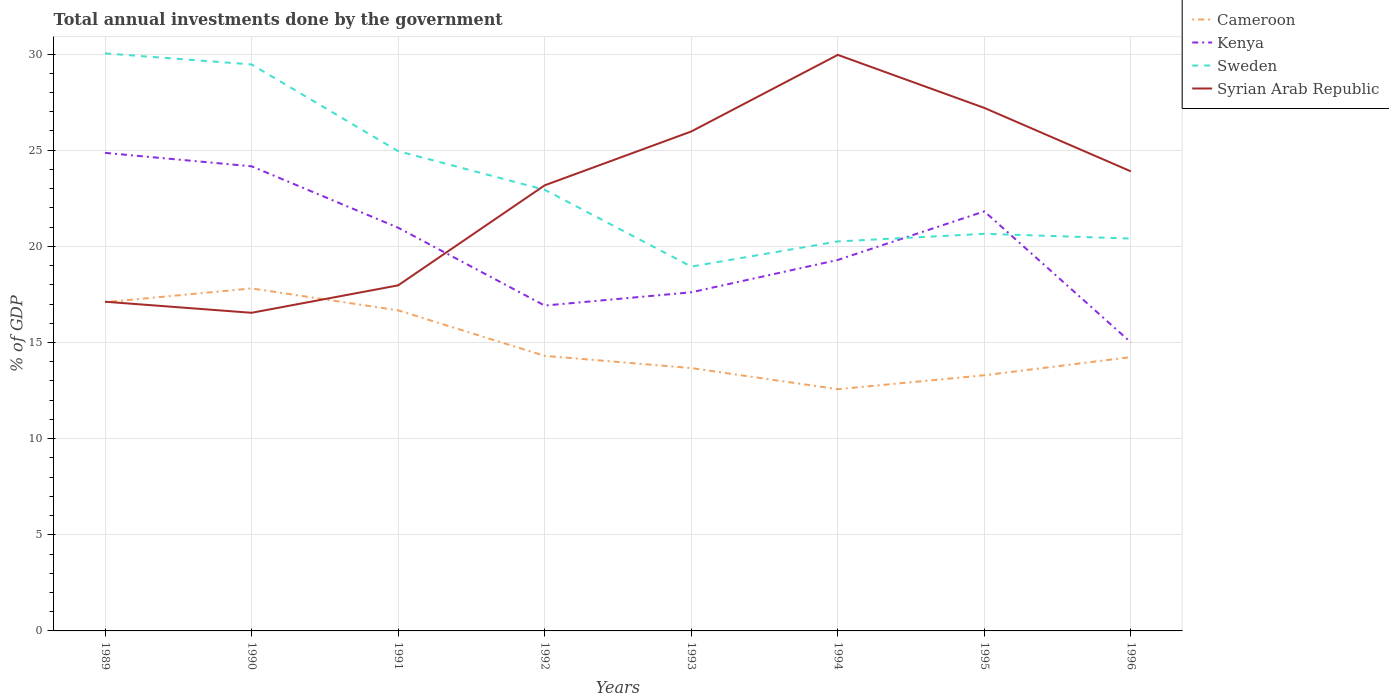Does the line corresponding to Syrian Arab Republic intersect with the line corresponding to Cameroon?
Offer a terse response. Yes. Is the number of lines equal to the number of legend labels?
Give a very brief answer. Yes. Across all years, what is the maximum total annual investments done by the government in Sweden?
Offer a very short reply. 18.95. What is the total total annual investments done by the government in Cameroon in the graph?
Ensure brevity in your answer.  2.79. What is the difference between the highest and the second highest total annual investments done by the government in Sweden?
Your answer should be compact. 11.09. Is the total annual investments done by the government in Cameroon strictly greater than the total annual investments done by the government in Sweden over the years?
Keep it short and to the point. Yes. How many lines are there?
Give a very brief answer. 4. How many years are there in the graph?
Provide a succinct answer. 8. What is the difference between two consecutive major ticks on the Y-axis?
Your answer should be very brief. 5. Are the values on the major ticks of Y-axis written in scientific E-notation?
Your response must be concise. No. Where does the legend appear in the graph?
Provide a short and direct response. Top right. How many legend labels are there?
Your answer should be compact. 4. What is the title of the graph?
Offer a terse response. Total annual investments done by the government. Does "Yemen, Rep." appear as one of the legend labels in the graph?
Offer a terse response. No. What is the label or title of the X-axis?
Provide a succinct answer. Years. What is the label or title of the Y-axis?
Ensure brevity in your answer.  % of GDP. What is the % of GDP in Cameroon in 1989?
Provide a succinct answer. 17.1. What is the % of GDP in Kenya in 1989?
Your response must be concise. 24.86. What is the % of GDP of Sweden in 1989?
Provide a short and direct response. 30.04. What is the % of GDP of Syrian Arab Republic in 1989?
Offer a very short reply. 17.12. What is the % of GDP in Cameroon in 1990?
Your answer should be compact. 17.81. What is the % of GDP in Kenya in 1990?
Your answer should be very brief. 24.16. What is the % of GDP of Sweden in 1990?
Your answer should be compact. 29.46. What is the % of GDP in Syrian Arab Republic in 1990?
Your answer should be compact. 16.55. What is the % of GDP in Cameroon in 1991?
Your answer should be compact. 16.67. What is the % of GDP in Kenya in 1991?
Provide a short and direct response. 20.97. What is the % of GDP of Sweden in 1991?
Provide a succinct answer. 24.95. What is the % of GDP in Syrian Arab Republic in 1991?
Provide a succinct answer. 17.97. What is the % of GDP of Cameroon in 1992?
Your response must be concise. 14.31. What is the % of GDP in Kenya in 1992?
Your answer should be compact. 16.92. What is the % of GDP in Sweden in 1992?
Make the answer very short. 22.94. What is the % of GDP in Syrian Arab Republic in 1992?
Your answer should be very brief. 23.17. What is the % of GDP in Cameroon in 1993?
Provide a short and direct response. 13.67. What is the % of GDP of Kenya in 1993?
Provide a short and direct response. 17.61. What is the % of GDP of Sweden in 1993?
Give a very brief answer. 18.95. What is the % of GDP in Syrian Arab Republic in 1993?
Give a very brief answer. 25.97. What is the % of GDP of Cameroon in 1994?
Provide a succinct answer. 12.57. What is the % of GDP of Kenya in 1994?
Make the answer very short. 19.29. What is the % of GDP in Sweden in 1994?
Ensure brevity in your answer.  20.26. What is the % of GDP in Syrian Arab Republic in 1994?
Keep it short and to the point. 29.96. What is the % of GDP in Cameroon in 1995?
Offer a terse response. 13.3. What is the % of GDP in Kenya in 1995?
Your response must be concise. 21.82. What is the % of GDP in Sweden in 1995?
Your answer should be very brief. 20.65. What is the % of GDP of Syrian Arab Republic in 1995?
Offer a terse response. 27.2. What is the % of GDP of Cameroon in 1996?
Offer a terse response. 14.24. What is the % of GDP of Kenya in 1996?
Offer a very short reply. 15. What is the % of GDP of Sweden in 1996?
Offer a very short reply. 20.41. What is the % of GDP in Syrian Arab Republic in 1996?
Offer a terse response. 23.9. Across all years, what is the maximum % of GDP in Cameroon?
Your answer should be very brief. 17.81. Across all years, what is the maximum % of GDP in Kenya?
Your answer should be very brief. 24.86. Across all years, what is the maximum % of GDP in Sweden?
Keep it short and to the point. 30.04. Across all years, what is the maximum % of GDP of Syrian Arab Republic?
Your answer should be compact. 29.96. Across all years, what is the minimum % of GDP of Cameroon?
Offer a very short reply. 12.57. Across all years, what is the minimum % of GDP of Kenya?
Give a very brief answer. 15. Across all years, what is the minimum % of GDP of Sweden?
Offer a very short reply. 18.95. Across all years, what is the minimum % of GDP in Syrian Arab Republic?
Offer a very short reply. 16.55. What is the total % of GDP of Cameroon in the graph?
Your response must be concise. 119.66. What is the total % of GDP of Kenya in the graph?
Your answer should be compact. 160.64. What is the total % of GDP of Sweden in the graph?
Offer a very short reply. 187.66. What is the total % of GDP of Syrian Arab Republic in the graph?
Give a very brief answer. 181.84. What is the difference between the % of GDP of Cameroon in 1989 and that in 1990?
Keep it short and to the point. -0.72. What is the difference between the % of GDP in Kenya in 1989 and that in 1990?
Make the answer very short. 0.7. What is the difference between the % of GDP in Sweden in 1989 and that in 1990?
Your response must be concise. 0.58. What is the difference between the % of GDP of Syrian Arab Republic in 1989 and that in 1990?
Provide a short and direct response. 0.58. What is the difference between the % of GDP of Cameroon in 1989 and that in 1991?
Ensure brevity in your answer.  0.42. What is the difference between the % of GDP of Kenya in 1989 and that in 1991?
Ensure brevity in your answer.  3.89. What is the difference between the % of GDP of Sweden in 1989 and that in 1991?
Your response must be concise. 5.08. What is the difference between the % of GDP in Syrian Arab Republic in 1989 and that in 1991?
Your response must be concise. -0.85. What is the difference between the % of GDP of Cameroon in 1989 and that in 1992?
Your response must be concise. 2.79. What is the difference between the % of GDP of Kenya in 1989 and that in 1992?
Provide a short and direct response. 7.94. What is the difference between the % of GDP of Sweden in 1989 and that in 1992?
Your answer should be very brief. 7.09. What is the difference between the % of GDP of Syrian Arab Republic in 1989 and that in 1992?
Provide a succinct answer. -6.05. What is the difference between the % of GDP of Cameroon in 1989 and that in 1993?
Your answer should be compact. 3.42. What is the difference between the % of GDP of Kenya in 1989 and that in 1993?
Provide a short and direct response. 7.25. What is the difference between the % of GDP of Sweden in 1989 and that in 1993?
Your answer should be compact. 11.09. What is the difference between the % of GDP in Syrian Arab Republic in 1989 and that in 1993?
Provide a short and direct response. -8.85. What is the difference between the % of GDP of Cameroon in 1989 and that in 1994?
Provide a succinct answer. 4.53. What is the difference between the % of GDP of Kenya in 1989 and that in 1994?
Provide a succinct answer. 5.57. What is the difference between the % of GDP in Sweden in 1989 and that in 1994?
Your response must be concise. 9.78. What is the difference between the % of GDP in Syrian Arab Republic in 1989 and that in 1994?
Make the answer very short. -12.84. What is the difference between the % of GDP in Cameroon in 1989 and that in 1995?
Provide a short and direct response. 3.8. What is the difference between the % of GDP in Kenya in 1989 and that in 1995?
Your response must be concise. 3.04. What is the difference between the % of GDP in Sweden in 1989 and that in 1995?
Give a very brief answer. 9.38. What is the difference between the % of GDP in Syrian Arab Republic in 1989 and that in 1995?
Give a very brief answer. -10.08. What is the difference between the % of GDP in Cameroon in 1989 and that in 1996?
Provide a succinct answer. 2.86. What is the difference between the % of GDP of Kenya in 1989 and that in 1996?
Offer a terse response. 9.86. What is the difference between the % of GDP of Sweden in 1989 and that in 1996?
Keep it short and to the point. 9.63. What is the difference between the % of GDP in Syrian Arab Republic in 1989 and that in 1996?
Offer a terse response. -6.78. What is the difference between the % of GDP in Cameroon in 1990 and that in 1991?
Give a very brief answer. 1.14. What is the difference between the % of GDP in Kenya in 1990 and that in 1991?
Your answer should be compact. 3.19. What is the difference between the % of GDP of Sweden in 1990 and that in 1991?
Give a very brief answer. 4.51. What is the difference between the % of GDP in Syrian Arab Republic in 1990 and that in 1991?
Make the answer very short. -1.43. What is the difference between the % of GDP in Cameroon in 1990 and that in 1992?
Your answer should be very brief. 3.51. What is the difference between the % of GDP in Kenya in 1990 and that in 1992?
Your response must be concise. 7.24. What is the difference between the % of GDP of Sweden in 1990 and that in 1992?
Your response must be concise. 6.52. What is the difference between the % of GDP of Syrian Arab Republic in 1990 and that in 1992?
Your answer should be very brief. -6.63. What is the difference between the % of GDP in Cameroon in 1990 and that in 1993?
Give a very brief answer. 4.14. What is the difference between the % of GDP in Kenya in 1990 and that in 1993?
Make the answer very short. 6.55. What is the difference between the % of GDP of Sweden in 1990 and that in 1993?
Keep it short and to the point. 10.51. What is the difference between the % of GDP in Syrian Arab Republic in 1990 and that in 1993?
Offer a terse response. -9.43. What is the difference between the % of GDP in Cameroon in 1990 and that in 1994?
Provide a short and direct response. 5.24. What is the difference between the % of GDP of Kenya in 1990 and that in 1994?
Offer a terse response. 4.87. What is the difference between the % of GDP in Sweden in 1990 and that in 1994?
Ensure brevity in your answer.  9.2. What is the difference between the % of GDP of Syrian Arab Republic in 1990 and that in 1994?
Your response must be concise. -13.41. What is the difference between the % of GDP of Cameroon in 1990 and that in 1995?
Your answer should be very brief. 4.52. What is the difference between the % of GDP of Kenya in 1990 and that in 1995?
Offer a very short reply. 2.34. What is the difference between the % of GDP of Sweden in 1990 and that in 1995?
Provide a succinct answer. 8.81. What is the difference between the % of GDP in Syrian Arab Republic in 1990 and that in 1995?
Make the answer very short. -10.65. What is the difference between the % of GDP of Cameroon in 1990 and that in 1996?
Keep it short and to the point. 3.57. What is the difference between the % of GDP in Kenya in 1990 and that in 1996?
Give a very brief answer. 9.16. What is the difference between the % of GDP of Sweden in 1990 and that in 1996?
Your answer should be compact. 9.06. What is the difference between the % of GDP of Syrian Arab Republic in 1990 and that in 1996?
Your answer should be very brief. -7.36. What is the difference between the % of GDP of Cameroon in 1991 and that in 1992?
Make the answer very short. 2.37. What is the difference between the % of GDP in Kenya in 1991 and that in 1992?
Ensure brevity in your answer.  4.05. What is the difference between the % of GDP in Sweden in 1991 and that in 1992?
Your response must be concise. 2.01. What is the difference between the % of GDP in Syrian Arab Republic in 1991 and that in 1992?
Give a very brief answer. -5.2. What is the difference between the % of GDP in Cameroon in 1991 and that in 1993?
Keep it short and to the point. 3. What is the difference between the % of GDP of Kenya in 1991 and that in 1993?
Your response must be concise. 3.36. What is the difference between the % of GDP of Sweden in 1991 and that in 1993?
Make the answer very short. 6. What is the difference between the % of GDP in Syrian Arab Republic in 1991 and that in 1993?
Make the answer very short. -8. What is the difference between the % of GDP in Cameroon in 1991 and that in 1994?
Your answer should be very brief. 4.1. What is the difference between the % of GDP of Kenya in 1991 and that in 1994?
Keep it short and to the point. 1.68. What is the difference between the % of GDP in Sweden in 1991 and that in 1994?
Provide a succinct answer. 4.7. What is the difference between the % of GDP of Syrian Arab Republic in 1991 and that in 1994?
Your response must be concise. -11.99. What is the difference between the % of GDP of Cameroon in 1991 and that in 1995?
Your answer should be compact. 3.38. What is the difference between the % of GDP of Kenya in 1991 and that in 1995?
Provide a succinct answer. -0.85. What is the difference between the % of GDP in Sweden in 1991 and that in 1995?
Give a very brief answer. 4.3. What is the difference between the % of GDP of Syrian Arab Republic in 1991 and that in 1995?
Give a very brief answer. -9.23. What is the difference between the % of GDP of Cameroon in 1991 and that in 1996?
Your answer should be compact. 2.43. What is the difference between the % of GDP of Kenya in 1991 and that in 1996?
Keep it short and to the point. 5.97. What is the difference between the % of GDP of Sweden in 1991 and that in 1996?
Provide a succinct answer. 4.55. What is the difference between the % of GDP of Syrian Arab Republic in 1991 and that in 1996?
Keep it short and to the point. -5.93. What is the difference between the % of GDP in Cameroon in 1992 and that in 1993?
Provide a short and direct response. 0.63. What is the difference between the % of GDP in Kenya in 1992 and that in 1993?
Keep it short and to the point. -0.69. What is the difference between the % of GDP in Sweden in 1992 and that in 1993?
Give a very brief answer. 4. What is the difference between the % of GDP in Syrian Arab Republic in 1992 and that in 1993?
Keep it short and to the point. -2.8. What is the difference between the % of GDP in Cameroon in 1992 and that in 1994?
Your answer should be very brief. 1.73. What is the difference between the % of GDP in Kenya in 1992 and that in 1994?
Your answer should be compact. -2.37. What is the difference between the % of GDP of Sweden in 1992 and that in 1994?
Provide a short and direct response. 2.69. What is the difference between the % of GDP of Syrian Arab Republic in 1992 and that in 1994?
Keep it short and to the point. -6.79. What is the difference between the % of GDP in Cameroon in 1992 and that in 1995?
Give a very brief answer. 1.01. What is the difference between the % of GDP in Kenya in 1992 and that in 1995?
Give a very brief answer. -4.9. What is the difference between the % of GDP in Sweden in 1992 and that in 1995?
Your answer should be compact. 2.29. What is the difference between the % of GDP in Syrian Arab Republic in 1992 and that in 1995?
Your response must be concise. -4.03. What is the difference between the % of GDP in Cameroon in 1992 and that in 1996?
Keep it short and to the point. 0.07. What is the difference between the % of GDP in Kenya in 1992 and that in 1996?
Keep it short and to the point. 1.92. What is the difference between the % of GDP of Sweden in 1992 and that in 1996?
Offer a terse response. 2.54. What is the difference between the % of GDP in Syrian Arab Republic in 1992 and that in 1996?
Your answer should be compact. -0.73. What is the difference between the % of GDP in Cameroon in 1993 and that in 1994?
Your answer should be compact. 1.1. What is the difference between the % of GDP of Kenya in 1993 and that in 1994?
Offer a terse response. -1.68. What is the difference between the % of GDP of Sweden in 1993 and that in 1994?
Provide a succinct answer. -1.31. What is the difference between the % of GDP of Syrian Arab Republic in 1993 and that in 1994?
Ensure brevity in your answer.  -3.99. What is the difference between the % of GDP in Cameroon in 1993 and that in 1995?
Keep it short and to the point. 0.37. What is the difference between the % of GDP in Kenya in 1993 and that in 1995?
Ensure brevity in your answer.  -4.21. What is the difference between the % of GDP in Sweden in 1993 and that in 1995?
Keep it short and to the point. -1.7. What is the difference between the % of GDP of Syrian Arab Republic in 1993 and that in 1995?
Your response must be concise. -1.23. What is the difference between the % of GDP in Cameroon in 1993 and that in 1996?
Provide a short and direct response. -0.57. What is the difference between the % of GDP in Kenya in 1993 and that in 1996?
Provide a short and direct response. 2.61. What is the difference between the % of GDP of Sweden in 1993 and that in 1996?
Your answer should be very brief. -1.46. What is the difference between the % of GDP of Syrian Arab Republic in 1993 and that in 1996?
Your answer should be compact. 2.07. What is the difference between the % of GDP of Cameroon in 1994 and that in 1995?
Give a very brief answer. -0.73. What is the difference between the % of GDP in Kenya in 1994 and that in 1995?
Offer a terse response. -2.53. What is the difference between the % of GDP in Sweden in 1994 and that in 1995?
Ensure brevity in your answer.  -0.4. What is the difference between the % of GDP of Syrian Arab Republic in 1994 and that in 1995?
Provide a succinct answer. 2.76. What is the difference between the % of GDP in Cameroon in 1994 and that in 1996?
Keep it short and to the point. -1.67. What is the difference between the % of GDP of Kenya in 1994 and that in 1996?
Offer a very short reply. 4.29. What is the difference between the % of GDP of Sweden in 1994 and that in 1996?
Keep it short and to the point. -0.15. What is the difference between the % of GDP of Syrian Arab Republic in 1994 and that in 1996?
Keep it short and to the point. 6.06. What is the difference between the % of GDP of Cameroon in 1995 and that in 1996?
Your answer should be very brief. -0.94. What is the difference between the % of GDP in Kenya in 1995 and that in 1996?
Provide a succinct answer. 6.82. What is the difference between the % of GDP in Sweden in 1995 and that in 1996?
Give a very brief answer. 0.25. What is the difference between the % of GDP in Syrian Arab Republic in 1995 and that in 1996?
Ensure brevity in your answer.  3.3. What is the difference between the % of GDP of Cameroon in 1989 and the % of GDP of Kenya in 1990?
Your answer should be compact. -7.07. What is the difference between the % of GDP in Cameroon in 1989 and the % of GDP in Sweden in 1990?
Provide a succinct answer. -12.36. What is the difference between the % of GDP in Cameroon in 1989 and the % of GDP in Syrian Arab Republic in 1990?
Offer a very short reply. 0.55. What is the difference between the % of GDP in Kenya in 1989 and the % of GDP in Sweden in 1990?
Make the answer very short. -4.6. What is the difference between the % of GDP of Kenya in 1989 and the % of GDP of Syrian Arab Republic in 1990?
Offer a terse response. 8.32. What is the difference between the % of GDP in Sweden in 1989 and the % of GDP in Syrian Arab Republic in 1990?
Offer a terse response. 13.49. What is the difference between the % of GDP in Cameroon in 1989 and the % of GDP in Kenya in 1991?
Offer a terse response. -3.87. What is the difference between the % of GDP of Cameroon in 1989 and the % of GDP of Sweden in 1991?
Your answer should be very brief. -7.86. What is the difference between the % of GDP of Cameroon in 1989 and the % of GDP of Syrian Arab Republic in 1991?
Your response must be concise. -0.88. What is the difference between the % of GDP of Kenya in 1989 and the % of GDP of Sweden in 1991?
Offer a terse response. -0.09. What is the difference between the % of GDP of Kenya in 1989 and the % of GDP of Syrian Arab Republic in 1991?
Give a very brief answer. 6.89. What is the difference between the % of GDP in Sweden in 1989 and the % of GDP in Syrian Arab Republic in 1991?
Give a very brief answer. 12.07. What is the difference between the % of GDP in Cameroon in 1989 and the % of GDP in Kenya in 1992?
Provide a short and direct response. 0.18. What is the difference between the % of GDP in Cameroon in 1989 and the % of GDP in Sweden in 1992?
Keep it short and to the point. -5.85. What is the difference between the % of GDP of Cameroon in 1989 and the % of GDP of Syrian Arab Republic in 1992?
Your response must be concise. -6.08. What is the difference between the % of GDP of Kenya in 1989 and the % of GDP of Sweden in 1992?
Give a very brief answer. 1.92. What is the difference between the % of GDP in Kenya in 1989 and the % of GDP in Syrian Arab Republic in 1992?
Your answer should be compact. 1.69. What is the difference between the % of GDP of Sweden in 1989 and the % of GDP of Syrian Arab Republic in 1992?
Your response must be concise. 6.86. What is the difference between the % of GDP of Cameroon in 1989 and the % of GDP of Kenya in 1993?
Provide a short and direct response. -0.51. What is the difference between the % of GDP of Cameroon in 1989 and the % of GDP of Sweden in 1993?
Your answer should be compact. -1.85. What is the difference between the % of GDP in Cameroon in 1989 and the % of GDP in Syrian Arab Republic in 1993?
Your answer should be very brief. -8.88. What is the difference between the % of GDP of Kenya in 1989 and the % of GDP of Sweden in 1993?
Provide a short and direct response. 5.91. What is the difference between the % of GDP of Kenya in 1989 and the % of GDP of Syrian Arab Republic in 1993?
Ensure brevity in your answer.  -1.11. What is the difference between the % of GDP in Sweden in 1989 and the % of GDP in Syrian Arab Republic in 1993?
Offer a very short reply. 4.06. What is the difference between the % of GDP in Cameroon in 1989 and the % of GDP in Kenya in 1994?
Your answer should be very brief. -2.2. What is the difference between the % of GDP in Cameroon in 1989 and the % of GDP in Sweden in 1994?
Offer a terse response. -3.16. What is the difference between the % of GDP of Cameroon in 1989 and the % of GDP of Syrian Arab Republic in 1994?
Provide a short and direct response. -12.86. What is the difference between the % of GDP of Kenya in 1989 and the % of GDP of Sweden in 1994?
Ensure brevity in your answer.  4.61. What is the difference between the % of GDP in Kenya in 1989 and the % of GDP in Syrian Arab Republic in 1994?
Offer a very short reply. -5.1. What is the difference between the % of GDP in Sweden in 1989 and the % of GDP in Syrian Arab Republic in 1994?
Provide a succinct answer. 0.08. What is the difference between the % of GDP of Cameroon in 1989 and the % of GDP of Kenya in 1995?
Ensure brevity in your answer.  -4.72. What is the difference between the % of GDP of Cameroon in 1989 and the % of GDP of Sweden in 1995?
Your response must be concise. -3.56. What is the difference between the % of GDP in Cameroon in 1989 and the % of GDP in Syrian Arab Republic in 1995?
Ensure brevity in your answer.  -10.1. What is the difference between the % of GDP in Kenya in 1989 and the % of GDP in Sweden in 1995?
Provide a short and direct response. 4.21. What is the difference between the % of GDP of Kenya in 1989 and the % of GDP of Syrian Arab Republic in 1995?
Give a very brief answer. -2.34. What is the difference between the % of GDP of Sweden in 1989 and the % of GDP of Syrian Arab Republic in 1995?
Your answer should be very brief. 2.84. What is the difference between the % of GDP of Cameroon in 1989 and the % of GDP of Kenya in 1996?
Provide a succinct answer. 2.09. What is the difference between the % of GDP in Cameroon in 1989 and the % of GDP in Sweden in 1996?
Offer a very short reply. -3.31. What is the difference between the % of GDP of Cameroon in 1989 and the % of GDP of Syrian Arab Republic in 1996?
Provide a short and direct response. -6.8. What is the difference between the % of GDP of Kenya in 1989 and the % of GDP of Sweden in 1996?
Keep it short and to the point. 4.46. What is the difference between the % of GDP in Kenya in 1989 and the % of GDP in Syrian Arab Republic in 1996?
Give a very brief answer. 0.96. What is the difference between the % of GDP in Sweden in 1989 and the % of GDP in Syrian Arab Republic in 1996?
Keep it short and to the point. 6.14. What is the difference between the % of GDP of Cameroon in 1990 and the % of GDP of Kenya in 1991?
Provide a short and direct response. -3.16. What is the difference between the % of GDP of Cameroon in 1990 and the % of GDP of Sweden in 1991?
Offer a terse response. -7.14. What is the difference between the % of GDP in Cameroon in 1990 and the % of GDP in Syrian Arab Republic in 1991?
Your response must be concise. -0.16. What is the difference between the % of GDP of Kenya in 1990 and the % of GDP of Sweden in 1991?
Provide a succinct answer. -0.79. What is the difference between the % of GDP of Kenya in 1990 and the % of GDP of Syrian Arab Republic in 1991?
Offer a very short reply. 6.19. What is the difference between the % of GDP in Sweden in 1990 and the % of GDP in Syrian Arab Republic in 1991?
Keep it short and to the point. 11.49. What is the difference between the % of GDP of Cameroon in 1990 and the % of GDP of Kenya in 1992?
Provide a succinct answer. 0.89. What is the difference between the % of GDP in Cameroon in 1990 and the % of GDP in Sweden in 1992?
Your answer should be compact. -5.13. What is the difference between the % of GDP in Cameroon in 1990 and the % of GDP in Syrian Arab Republic in 1992?
Your answer should be compact. -5.36. What is the difference between the % of GDP in Kenya in 1990 and the % of GDP in Sweden in 1992?
Give a very brief answer. 1.22. What is the difference between the % of GDP in Kenya in 1990 and the % of GDP in Syrian Arab Republic in 1992?
Your answer should be compact. 0.99. What is the difference between the % of GDP of Sweden in 1990 and the % of GDP of Syrian Arab Republic in 1992?
Give a very brief answer. 6.29. What is the difference between the % of GDP of Cameroon in 1990 and the % of GDP of Kenya in 1993?
Your answer should be very brief. 0.2. What is the difference between the % of GDP in Cameroon in 1990 and the % of GDP in Sweden in 1993?
Provide a short and direct response. -1.14. What is the difference between the % of GDP of Cameroon in 1990 and the % of GDP of Syrian Arab Republic in 1993?
Provide a short and direct response. -8.16. What is the difference between the % of GDP of Kenya in 1990 and the % of GDP of Sweden in 1993?
Provide a succinct answer. 5.22. What is the difference between the % of GDP in Kenya in 1990 and the % of GDP in Syrian Arab Republic in 1993?
Keep it short and to the point. -1.81. What is the difference between the % of GDP of Sweden in 1990 and the % of GDP of Syrian Arab Republic in 1993?
Your response must be concise. 3.49. What is the difference between the % of GDP in Cameroon in 1990 and the % of GDP in Kenya in 1994?
Provide a short and direct response. -1.48. What is the difference between the % of GDP of Cameroon in 1990 and the % of GDP of Sweden in 1994?
Ensure brevity in your answer.  -2.44. What is the difference between the % of GDP in Cameroon in 1990 and the % of GDP in Syrian Arab Republic in 1994?
Make the answer very short. -12.15. What is the difference between the % of GDP in Kenya in 1990 and the % of GDP in Sweden in 1994?
Give a very brief answer. 3.91. What is the difference between the % of GDP in Kenya in 1990 and the % of GDP in Syrian Arab Republic in 1994?
Make the answer very short. -5.79. What is the difference between the % of GDP in Sweden in 1990 and the % of GDP in Syrian Arab Republic in 1994?
Provide a short and direct response. -0.5. What is the difference between the % of GDP of Cameroon in 1990 and the % of GDP of Kenya in 1995?
Make the answer very short. -4.01. What is the difference between the % of GDP in Cameroon in 1990 and the % of GDP in Sweden in 1995?
Provide a succinct answer. -2.84. What is the difference between the % of GDP in Cameroon in 1990 and the % of GDP in Syrian Arab Republic in 1995?
Make the answer very short. -9.39. What is the difference between the % of GDP of Kenya in 1990 and the % of GDP of Sweden in 1995?
Make the answer very short. 3.51. What is the difference between the % of GDP in Kenya in 1990 and the % of GDP in Syrian Arab Republic in 1995?
Provide a short and direct response. -3.04. What is the difference between the % of GDP in Sweden in 1990 and the % of GDP in Syrian Arab Republic in 1995?
Offer a very short reply. 2.26. What is the difference between the % of GDP in Cameroon in 1990 and the % of GDP in Kenya in 1996?
Provide a succinct answer. 2.81. What is the difference between the % of GDP of Cameroon in 1990 and the % of GDP of Sweden in 1996?
Ensure brevity in your answer.  -2.59. What is the difference between the % of GDP of Cameroon in 1990 and the % of GDP of Syrian Arab Republic in 1996?
Provide a short and direct response. -6.09. What is the difference between the % of GDP in Kenya in 1990 and the % of GDP in Sweden in 1996?
Offer a terse response. 3.76. What is the difference between the % of GDP of Kenya in 1990 and the % of GDP of Syrian Arab Republic in 1996?
Provide a short and direct response. 0.26. What is the difference between the % of GDP in Sweden in 1990 and the % of GDP in Syrian Arab Republic in 1996?
Give a very brief answer. 5.56. What is the difference between the % of GDP in Cameroon in 1991 and the % of GDP in Kenya in 1992?
Keep it short and to the point. -0.25. What is the difference between the % of GDP in Cameroon in 1991 and the % of GDP in Sweden in 1992?
Make the answer very short. -6.27. What is the difference between the % of GDP of Cameroon in 1991 and the % of GDP of Syrian Arab Republic in 1992?
Provide a succinct answer. -6.5. What is the difference between the % of GDP of Kenya in 1991 and the % of GDP of Sweden in 1992?
Your answer should be compact. -1.97. What is the difference between the % of GDP of Kenya in 1991 and the % of GDP of Syrian Arab Republic in 1992?
Your response must be concise. -2.2. What is the difference between the % of GDP of Sweden in 1991 and the % of GDP of Syrian Arab Republic in 1992?
Offer a terse response. 1.78. What is the difference between the % of GDP in Cameroon in 1991 and the % of GDP in Kenya in 1993?
Give a very brief answer. -0.94. What is the difference between the % of GDP of Cameroon in 1991 and the % of GDP of Sweden in 1993?
Your response must be concise. -2.28. What is the difference between the % of GDP of Cameroon in 1991 and the % of GDP of Syrian Arab Republic in 1993?
Give a very brief answer. -9.3. What is the difference between the % of GDP of Kenya in 1991 and the % of GDP of Sweden in 1993?
Provide a short and direct response. 2.02. What is the difference between the % of GDP in Kenya in 1991 and the % of GDP in Syrian Arab Republic in 1993?
Make the answer very short. -5. What is the difference between the % of GDP of Sweden in 1991 and the % of GDP of Syrian Arab Republic in 1993?
Offer a terse response. -1.02. What is the difference between the % of GDP of Cameroon in 1991 and the % of GDP of Kenya in 1994?
Make the answer very short. -2.62. What is the difference between the % of GDP of Cameroon in 1991 and the % of GDP of Sweden in 1994?
Offer a very short reply. -3.58. What is the difference between the % of GDP of Cameroon in 1991 and the % of GDP of Syrian Arab Republic in 1994?
Keep it short and to the point. -13.29. What is the difference between the % of GDP in Kenya in 1991 and the % of GDP in Sweden in 1994?
Your answer should be compact. 0.71. What is the difference between the % of GDP in Kenya in 1991 and the % of GDP in Syrian Arab Republic in 1994?
Provide a short and direct response. -8.99. What is the difference between the % of GDP of Sweden in 1991 and the % of GDP of Syrian Arab Republic in 1994?
Ensure brevity in your answer.  -5.01. What is the difference between the % of GDP of Cameroon in 1991 and the % of GDP of Kenya in 1995?
Provide a succinct answer. -5.15. What is the difference between the % of GDP in Cameroon in 1991 and the % of GDP in Sweden in 1995?
Your response must be concise. -3.98. What is the difference between the % of GDP of Cameroon in 1991 and the % of GDP of Syrian Arab Republic in 1995?
Your answer should be compact. -10.53. What is the difference between the % of GDP of Kenya in 1991 and the % of GDP of Sweden in 1995?
Provide a succinct answer. 0.32. What is the difference between the % of GDP of Kenya in 1991 and the % of GDP of Syrian Arab Republic in 1995?
Give a very brief answer. -6.23. What is the difference between the % of GDP in Sweden in 1991 and the % of GDP in Syrian Arab Republic in 1995?
Provide a short and direct response. -2.25. What is the difference between the % of GDP of Cameroon in 1991 and the % of GDP of Kenya in 1996?
Provide a short and direct response. 1.67. What is the difference between the % of GDP in Cameroon in 1991 and the % of GDP in Sweden in 1996?
Provide a short and direct response. -3.73. What is the difference between the % of GDP of Cameroon in 1991 and the % of GDP of Syrian Arab Republic in 1996?
Offer a very short reply. -7.23. What is the difference between the % of GDP in Kenya in 1991 and the % of GDP in Sweden in 1996?
Keep it short and to the point. 0.57. What is the difference between the % of GDP of Kenya in 1991 and the % of GDP of Syrian Arab Republic in 1996?
Provide a short and direct response. -2.93. What is the difference between the % of GDP of Sweden in 1991 and the % of GDP of Syrian Arab Republic in 1996?
Offer a very short reply. 1.05. What is the difference between the % of GDP in Cameroon in 1992 and the % of GDP in Kenya in 1993?
Provide a succinct answer. -3.31. What is the difference between the % of GDP in Cameroon in 1992 and the % of GDP in Sweden in 1993?
Give a very brief answer. -4.64. What is the difference between the % of GDP of Cameroon in 1992 and the % of GDP of Syrian Arab Republic in 1993?
Give a very brief answer. -11.67. What is the difference between the % of GDP in Kenya in 1992 and the % of GDP in Sweden in 1993?
Provide a short and direct response. -2.03. What is the difference between the % of GDP in Kenya in 1992 and the % of GDP in Syrian Arab Republic in 1993?
Offer a very short reply. -9.05. What is the difference between the % of GDP in Sweden in 1992 and the % of GDP in Syrian Arab Republic in 1993?
Your response must be concise. -3.03. What is the difference between the % of GDP in Cameroon in 1992 and the % of GDP in Kenya in 1994?
Provide a succinct answer. -4.99. What is the difference between the % of GDP in Cameroon in 1992 and the % of GDP in Sweden in 1994?
Provide a succinct answer. -5.95. What is the difference between the % of GDP in Cameroon in 1992 and the % of GDP in Syrian Arab Republic in 1994?
Your answer should be compact. -15.65. What is the difference between the % of GDP of Kenya in 1992 and the % of GDP of Sweden in 1994?
Your response must be concise. -3.34. What is the difference between the % of GDP in Kenya in 1992 and the % of GDP in Syrian Arab Republic in 1994?
Make the answer very short. -13.04. What is the difference between the % of GDP in Sweden in 1992 and the % of GDP in Syrian Arab Republic in 1994?
Your answer should be very brief. -7.02. What is the difference between the % of GDP of Cameroon in 1992 and the % of GDP of Kenya in 1995?
Offer a terse response. -7.51. What is the difference between the % of GDP in Cameroon in 1992 and the % of GDP in Sweden in 1995?
Your response must be concise. -6.35. What is the difference between the % of GDP of Cameroon in 1992 and the % of GDP of Syrian Arab Republic in 1995?
Keep it short and to the point. -12.89. What is the difference between the % of GDP of Kenya in 1992 and the % of GDP of Sweden in 1995?
Your answer should be compact. -3.73. What is the difference between the % of GDP of Kenya in 1992 and the % of GDP of Syrian Arab Republic in 1995?
Your answer should be very brief. -10.28. What is the difference between the % of GDP of Sweden in 1992 and the % of GDP of Syrian Arab Republic in 1995?
Your answer should be very brief. -4.26. What is the difference between the % of GDP of Cameroon in 1992 and the % of GDP of Kenya in 1996?
Your response must be concise. -0.7. What is the difference between the % of GDP of Cameroon in 1992 and the % of GDP of Sweden in 1996?
Provide a succinct answer. -6.1. What is the difference between the % of GDP of Cameroon in 1992 and the % of GDP of Syrian Arab Republic in 1996?
Provide a succinct answer. -9.59. What is the difference between the % of GDP in Kenya in 1992 and the % of GDP in Sweden in 1996?
Give a very brief answer. -3.48. What is the difference between the % of GDP in Kenya in 1992 and the % of GDP in Syrian Arab Republic in 1996?
Make the answer very short. -6.98. What is the difference between the % of GDP in Sweden in 1992 and the % of GDP in Syrian Arab Republic in 1996?
Your answer should be very brief. -0.96. What is the difference between the % of GDP in Cameroon in 1993 and the % of GDP in Kenya in 1994?
Offer a terse response. -5.62. What is the difference between the % of GDP of Cameroon in 1993 and the % of GDP of Sweden in 1994?
Your answer should be very brief. -6.58. What is the difference between the % of GDP in Cameroon in 1993 and the % of GDP in Syrian Arab Republic in 1994?
Give a very brief answer. -16.29. What is the difference between the % of GDP of Kenya in 1993 and the % of GDP of Sweden in 1994?
Your response must be concise. -2.65. What is the difference between the % of GDP of Kenya in 1993 and the % of GDP of Syrian Arab Republic in 1994?
Your response must be concise. -12.35. What is the difference between the % of GDP in Sweden in 1993 and the % of GDP in Syrian Arab Republic in 1994?
Offer a terse response. -11.01. What is the difference between the % of GDP of Cameroon in 1993 and the % of GDP of Kenya in 1995?
Give a very brief answer. -8.15. What is the difference between the % of GDP in Cameroon in 1993 and the % of GDP in Sweden in 1995?
Keep it short and to the point. -6.98. What is the difference between the % of GDP in Cameroon in 1993 and the % of GDP in Syrian Arab Republic in 1995?
Your answer should be compact. -13.53. What is the difference between the % of GDP in Kenya in 1993 and the % of GDP in Sweden in 1995?
Make the answer very short. -3.04. What is the difference between the % of GDP of Kenya in 1993 and the % of GDP of Syrian Arab Republic in 1995?
Your answer should be compact. -9.59. What is the difference between the % of GDP of Sweden in 1993 and the % of GDP of Syrian Arab Republic in 1995?
Make the answer very short. -8.25. What is the difference between the % of GDP of Cameroon in 1993 and the % of GDP of Kenya in 1996?
Ensure brevity in your answer.  -1.33. What is the difference between the % of GDP of Cameroon in 1993 and the % of GDP of Sweden in 1996?
Keep it short and to the point. -6.73. What is the difference between the % of GDP of Cameroon in 1993 and the % of GDP of Syrian Arab Republic in 1996?
Your answer should be compact. -10.23. What is the difference between the % of GDP of Kenya in 1993 and the % of GDP of Sweden in 1996?
Offer a terse response. -2.79. What is the difference between the % of GDP of Kenya in 1993 and the % of GDP of Syrian Arab Republic in 1996?
Provide a short and direct response. -6.29. What is the difference between the % of GDP in Sweden in 1993 and the % of GDP in Syrian Arab Republic in 1996?
Keep it short and to the point. -4.95. What is the difference between the % of GDP in Cameroon in 1994 and the % of GDP in Kenya in 1995?
Keep it short and to the point. -9.25. What is the difference between the % of GDP of Cameroon in 1994 and the % of GDP of Sweden in 1995?
Your answer should be very brief. -8.08. What is the difference between the % of GDP in Cameroon in 1994 and the % of GDP in Syrian Arab Republic in 1995?
Ensure brevity in your answer.  -14.63. What is the difference between the % of GDP of Kenya in 1994 and the % of GDP of Sweden in 1995?
Offer a terse response. -1.36. What is the difference between the % of GDP of Kenya in 1994 and the % of GDP of Syrian Arab Republic in 1995?
Provide a succinct answer. -7.91. What is the difference between the % of GDP of Sweden in 1994 and the % of GDP of Syrian Arab Republic in 1995?
Ensure brevity in your answer.  -6.94. What is the difference between the % of GDP of Cameroon in 1994 and the % of GDP of Kenya in 1996?
Provide a short and direct response. -2.43. What is the difference between the % of GDP in Cameroon in 1994 and the % of GDP in Sweden in 1996?
Your answer should be compact. -7.83. What is the difference between the % of GDP of Cameroon in 1994 and the % of GDP of Syrian Arab Republic in 1996?
Ensure brevity in your answer.  -11.33. What is the difference between the % of GDP in Kenya in 1994 and the % of GDP in Sweden in 1996?
Offer a terse response. -1.11. What is the difference between the % of GDP in Kenya in 1994 and the % of GDP in Syrian Arab Republic in 1996?
Your response must be concise. -4.61. What is the difference between the % of GDP in Sweden in 1994 and the % of GDP in Syrian Arab Republic in 1996?
Offer a very short reply. -3.64. What is the difference between the % of GDP of Cameroon in 1995 and the % of GDP of Kenya in 1996?
Give a very brief answer. -1.71. What is the difference between the % of GDP of Cameroon in 1995 and the % of GDP of Sweden in 1996?
Make the answer very short. -7.11. What is the difference between the % of GDP of Cameroon in 1995 and the % of GDP of Syrian Arab Republic in 1996?
Make the answer very short. -10.6. What is the difference between the % of GDP in Kenya in 1995 and the % of GDP in Sweden in 1996?
Make the answer very short. 1.41. What is the difference between the % of GDP in Kenya in 1995 and the % of GDP in Syrian Arab Republic in 1996?
Give a very brief answer. -2.08. What is the difference between the % of GDP of Sweden in 1995 and the % of GDP of Syrian Arab Republic in 1996?
Keep it short and to the point. -3.25. What is the average % of GDP of Cameroon per year?
Offer a very short reply. 14.96. What is the average % of GDP in Kenya per year?
Make the answer very short. 20.08. What is the average % of GDP of Sweden per year?
Your answer should be compact. 23.46. What is the average % of GDP in Syrian Arab Republic per year?
Provide a short and direct response. 22.73. In the year 1989, what is the difference between the % of GDP of Cameroon and % of GDP of Kenya?
Provide a succinct answer. -7.77. In the year 1989, what is the difference between the % of GDP of Cameroon and % of GDP of Sweden?
Give a very brief answer. -12.94. In the year 1989, what is the difference between the % of GDP of Cameroon and % of GDP of Syrian Arab Republic?
Keep it short and to the point. -0.02. In the year 1989, what is the difference between the % of GDP in Kenya and % of GDP in Sweden?
Your answer should be compact. -5.17. In the year 1989, what is the difference between the % of GDP in Kenya and % of GDP in Syrian Arab Republic?
Ensure brevity in your answer.  7.74. In the year 1989, what is the difference between the % of GDP in Sweden and % of GDP in Syrian Arab Republic?
Ensure brevity in your answer.  12.92. In the year 1990, what is the difference between the % of GDP in Cameroon and % of GDP in Kenya?
Make the answer very short. -6.35. In the year 1990, what is the difference between the % of GDP of Cameroon and % of GDP of Sweden?
Make the answer very short. -11.65. In the year 1990, what is the difference between the % of GDP in Cameroon and % of GDP in Syrian Arab Republic?
Offer a very short reply. 1.27. In the year 1990, what is the difference between the % of GDP in Kenya and % of GDP in Sweden?
Your answer should be very brief. -5.3. In the year 1990, what is the difference between the % of GDP in Kenya and % of GDP in Syrian Arab Republic?
Your answer should be compact. 7.62. In the year 1990, what is the difference between the % of GDP in Sweden and % of GDP in Syrian Arab Republic?
Offer a very short reply. 12.92. In the year 1991, what is the difference between the % of GDP in Cameroon and % of GDP in Kenya?
Ensure brevity in your answer.  -4.3. In the year 1991, what is the difference between the % of GDP in Cameroon and % of GDP in Sweden?
Ensure brevity in your answer.  -8.28. In the year 1991, what is the difference between the % of GDP of Cameroon and % of GDP of Syrian Arab Republic?
Make the answer very short. -1.3. In the year 1991, what is the difference between the % of GDP of Kenya and % of GDP of Sweden?
Keep it short and to the point. -3.98. In the year 1991, what is the difference between the % of GDP in Kenya and % of GDP in Syrian Arab Republic?
Keep it short and to the point. 3. In the year 1991, what is the difference between the % of GDP of Sweden and % of GDP of Syrian Arab Republic?
Ensure brevity in your answer.  6.98. In the year 1992, what is the difference between the % of GDP in Cameroon and % of GDP in Kenya?
Your response must be concise. -2.62. In the year 1992, what is the difference between the % of GDP of Cameroon and % of GDP of Sweden?
Ensure brevity in your answer.  -8.64. In the year 1992, what is the difference between the % of GDP in Cameroon and % of GDP in Syrian Arab Republic?
Offer a very short reply. -8.87. In the year 1992, what is the difference between the % of GDP in Kenya and % of GDP in Sweden?
Offer a terse response. -6.02. In the year 1992, what is the difference between the % of GDP of Kenya and % of GDP of Syrian Arab Republic?
Provide a short and direct response. -6.25. In the year 1992, what is the difference between the % of GDP of Sweden and % of GDP of Syrian Arab Republic?
Offer a terse response. -0.23. In the year 1993, what is the difference between the % of GDP of Cameroon and % of GDP of Kenya?
Your answer should be very brief. -3.94. In the year 1993, what is the difference between the % of GDP in Cameroon and % of GDP in Sweden?
Your answer should be compact. -5.28. In the year 1993, what is the difference between the % of GDP of Cameroon and % of GDP of Syrian Arab Republic?
Offer a terse response. -12.3. In the year 1993, what is the difference between the % of GDP of Kenya and % of GDP of Sweden?
Your answer should be compact. -1.34. In the year 1993, what is the difference between the % of GDP of Kenya and % of GDP of Syrian Arab Republic?
Provide a short and direct response. -8.36. In the year 1993, what is the difference between the % of GDP of Sweden and % of GDP of Syrian Arab Republic?
Keep it short and to the point. -7.02. In the year 1994, what is the difference between the % of GDP of Cameroon and % of GDP of Kenya?
Provide a short and direct response. -6.72. In the year 1994, what is the difference between the % of GDP in Cameroon and % of GDP in Sweden?
Ensure brevity in your answer.  -7.69. In the year 1994, what is the difference between the % of GDP in Cameroon and % of GDP in Syrian Arab Republic?
Keep it short and to the point. -17.39. In the year 1994, what is the difference between the % of GDP of Kenya and % of GDP of Sweden?
Provide a succinct answer. -0.96. In the year 1994, what is the difference between the % of GDP in Kenya and % of GDP in Syrian Arab Republic?
Your response must be concise. -10.67. In the year 1994, what is the difference between the % of GDP in Sweden and % of GDP in Syrian Arab Republic?
Offer a very short reply. -9.7. In the year 1995, what is the difference between the % of GDP in Cameroon and % of GDP in Kenya?
Your answer should be very brief. -8.52. In the year 1995, what is the difference between the % of GDP in Cameroon and % of GDP in Sweden?
Keep it short and to the point. -7.36. In the year 1995, what is the difference between the % of GDP of Cameroon and % of GDP of Syrian Arab Republic?
Your response must be concise. -13.9. In the year 1995, what is the difference between the % of GDP of Kenya and % of GDP of Sweden?
Provide a succinct answer. 1.17. In the year 1995, what is the difference between the % of GDP in Kenya and % of GDP in Syrian Arab Republic?
Your answer should be compact. -5.38. In the year 1995, what is the difference between the % of GDP of Sweden and % of GDP of Syrian Arab Republic?
Your answer should be compact. -6.55. In the year 1996, what is the difference between the % of GDP in Cameroon and % of GDP in Kenya?
Make the answer very short. -0.76. In the year 1996, what is the difference between the % of GDP of Cameroon and % of GDP of Sweden?
Provide a short and direct response. -6.17. In the year 1996, what is the difference between the % of GDP of Cameroon and % of GDP of Syrian Arab Republic?
Make the answer very short. -9.66. In the year 1996, what is the difference between the % of GDP in Kenya and % of GDP in Sweden?
Provide a short and direct response. -5.4. In the year 1996, what is the difference between the % of GDP in Kenya and % of GDP in Syrian Arab Republic?
Offer a terse response. -8.9. In the year 1996, what is the difference between the % of GDP of Sweden and % of GDP of Syrian Arab Republic?
Provide a short and direct response. -3.49. What is the ratio of the % of GDP in Cameroon in 1989 to that in 1990?
Provide a succinct answer. 0.96. What is the ratio of the % of GDP in Kenya in 1989 to that in 1990?
Your response must be concise. 1.03. What is the ratio of the % of GDP in Sweden in 1989 to that in 1990?
Provide a succinct answer. 1.02. What is the ratio of the % of GDP of Syrian Arab Republic in 1989 to that in 1990?
Give a very brief answer. 1.03. What is the ratio of the % of GDP in Cameroon in 1989 to that in 1991?
Your answer should be compact. 1.03. What is the ratio of the % of GDP in Kenya in 1989 to that in 1991?
Keep it short and to the point. 1.19. What is the ratio of the % of GDP in Sweden in 1989 to that in 1991?
Your answer should be very brief. 1.2. What is the ratio of the % of GDP of Syrian Arab Republic in 1989 to that in 1991?
Your answer should be very brief. 0.95. What is the ratio of the % of GDP of Cameroon in 1989 to that in 1992?
Your answer should be compact. 1.2. What is the ratio of the % of GDP in Kenya in 1989 to that in 1992?
Offer a very short reply. 1.47. What is the ratio of the % of GDP in Sweden in 1989 to that in 1992?
Provide a short and direct response. 1.31. What is the ratio of the % of GDP in Syrian Arab Republic in 1989 to that in 1992?
Your answer should be compact. 0.74. What is the ratio of the % of GDP of Cameroon in 1989 to that in 1993?
Give a very brief answer. 1.25. What is the ratio of the % of GDP in Kenya in 1989 to that in 1993?
Provide a short and direct response. 1.41. What is the ratio of the % of GDP of Sweden in 1989 to that in 1993?
Your response must be concise. 1.59. What is the ratio of the % of GDP of Syrian Arab Republic in 1989 to that in 1993?
Provide a succinct answer. 0.66. What is the ratio of the % of GDP in Cameroon in 1989 to that in 1994?
Your answer should be compact. 1.36. What is the ratio of the % of GDP of Kenya in 1989 to that in 1994?
Your response must be concise. 1.29. What is the ratio of the % of GDP of Sweden in 1989 to that in 1994?
Your response must be concise. 1.48. What is the ratio of the % of GDP in Syrian Arab Republic in 1989 to that in 1994?
Give a very brief answer. 0.57. What is the ratio of the % of GDP in Cameroon in 1989 to that in 1995?
Keep it short and to the point. 1.29. What is the ratio of the % of GDP of Kenya in 1989 to that in 1995?
Offer a very short reply. 1.14. What is the ratio of the % of GDP of Sweden in 1989 to that in 1995?
Your answer should be very brief. 1.45. What is the ratio of the % of GDP of Syrian Arab Republic in 1989 to that in 1995?
Keep it short and to the point. 0.63. What is the ratio of the % of GDP of Cameroon in 1989 to that in 1996?
Provide a succinct answer. 1.2. What is the ratio of the % of GDP in Kenya in 1989 to that in 1996?
Provide a succinct answer. 1.66. What is the ratio of the % of GDP in Sweden in 1989 to that in 1996?
Your response must be concise. 1.47. What is the ratio of the % of GDP of Syrian Arab Republic in 1989 to that in 1996?
Ensure brevity in your answer.  0.72. What is the ratio of the % of GDP in Cameroon in 1990 to that in 1991?
Offer a terse response. 1.07. What is the ratio of the % of GDP of Kenya in 1990 to that in 1991?
Make the answer very short. 1.15. What is the ratio of the % of GDP of Sweden in 1990 to that in 1991?
Make the answer very short. 1.18. What is the ratio of the % of GDP of Syrian Arab Republic in 1990 to that in 1991?
Your response must be concise. 0.92. What is the ratio of the % of GDP of Cameroon in 1990 to that in 1992?
Provide a short and direct response. 1.25. What is the ratio of the % of GDP in Kenya in 1990 to that in 1992?
Offer a very short reply. 1.43. What is the ratio of the % of GDP in Sweden in 1990 to that in 1992?
Give a very brief answer. 1.28. What is the ratio of the % of GDP of Syrian Arab Republic in 1990 to that in 1992?
Provide a succinct answer. 0.71. What is the ratio of the % of GDP of Cameroon in 1990 to that in 1993?
Make the answer very short. 1.3. What is the ratio of the % of GDP of Kenya in 1990 to that in 1993?
Your response must be concise. 1.37. What is the ratio of the % of GDP in Sweden in 1990 to that in 1993?
Offer a terse response. 1.55. What is the ratio of the % of GDP of Syrian Arab Republic in 1990 to that in 1993?
Provide a short and direct response. 0.64. What is the ratio of the % of GDP of Cameroon in 1990 to that in 1994?
Provide a succinct answer. 1.42. What is the ratio of the % of GDP in Kenya in 1990 to that in 1994?
Make the answer very short. 1.25. What is the ratio of the % of GDP in Sweden in 1990 to that in 1994?
Keep it short and to the point. 1.45. What is the ratio of the % of GDP in Syrian Arab Republic in 1990 to that in 1994?
Make the answer very short. 0.55. What is the ratio of the % of GDP of Cameroon in 1990 to that in 1995?
Offer a very short reply. 1.34. What is the ratio of the % of GDP of Kenya in 1990 to that in 1995?
Ensure brevity in your answer.  1.11. What is the ratio of the % of GDP of Sweden in 1990 to that in 1995?
Provide a short and direct response. 1.43. What is the ratio of the % of GDP in Syrian Arab Republic in 1990 to that in 1995?
Your response must be concise. 0.61. What is the ratio of the % of GDP in Cameroon in 1990 to that in 1996?
Provide a short and direct response. 1.25. What is the ratio of the % of GDP of Kenya in 1990 to that in 1996?
Make the answer very short. 1.61. What is the ratio of the % of GDP in Sweden in 1990 to that in 1996?
Your answer should be compact. 1.44. What is the ratio of the % of GDP in Syrian Arab Republic in 1990 to that in 1996?
Keep it short and to the point. 0.69. What is the ratio of the % of GDP in Cameroon in 1991 to that in 1992?
Provide a short and direct response. 1.17. What is the ratio of the % of GDP in Kenya in 1991 to that in 1992?
Offer a terse response. 1.24. What is the ratio of the % of GDP in Sweden in 1991 to that in 1992?
Give a very brief answer. 1.09. What is the ratio of the % of GDP in Syrian Arab Republic in 1991 to that in 1992?
Your answer should be very brief. 0.78. What is the ratio of the % of GDP of Cameroon in 1991 to that in 1993?
Provide a succinct answer. 1.22. What is the ratio of the % of GDP of Kenya in 1991 to that in 1993?
Provide a short and direct response. 1.19. What is the ratio of the % of GDP in Sweden in 1991 to that in 1993?
Offer a terse response. 1.32. What is the ratio of the % of GDP in Syrian Arab Republic in 1991 to that in 1993?
Give a very brief answer. 0.69. What is the ratio of the % of GDP of Cameroon in 1991 to that in 1994?
Make the answer very short. 1.33. What is the ratio of the % of GDP of Kenya in 1991 to that in 1994?
Provide a succinct answer. 1.09. What is the ratio of the % of GDP in Sweden in 1991 to that in 1994?
Your answer should be very brief. 1.23. What is the ratio of the % of GDP of Syrian Arab Republic in 1991 to that in 1994?
Your response must be concise. 0.6. What is the ratio of the % of GDP of Cameroon in 1991 to that in 1995?
Make the answer very short. 1.25. What is the ratio of the % of GDP of Kenya in 1991 to that in 1995?
Provide a succinct answer. 0.96. What is the ratio of the % of GDP in Sweden in 1991 to that in 1995?
Your response must be concise. 1.21. What is the ratio of the % of GDP in Syrian Arab Republic in 1991 to that in 1995?
Offer a very short reply. 0.66. What is the ratio of the % of GDP in Cameroon in 1991 to that in 1996?
Give a very brief answer. 1.17. What is the ratio of the % of GDP of Kenya in 1991 to that in 1996?
Provide a short and direct response. 1.4. What is the ratio of the % of GDP of Sweden in 1991 to that in 1996?
Provide a succinct answer. 1.22. What is the ratio of the % of GDP of Syrian Arab Republic in 1991 to that in 1996?
Offer a very short reply. 0.75. What is the ratio of the % of GDP in Cameroon in 1992 to that in 1993?
Your response must be concise. 1.05. What is the ratio of the % of GDP of Kenya in 1992 to that in 1993?
Offer a terse response. 0.96. What is the ratio of the % of GDP in Sweden in 1992 to that in 1993?
Give a very brief answer. 1.21. What is the ratio of the % of GDP of Syrian Arab Republic in 1992 to that in 1993?
Your answer should be very brief. 0.89. What is the ratio of the % of GDP in Cameroon in 1992 to that in 1994?
Provide a succinct answer. 1.14. What is the ratio of the % of GDP in Kenya in 1992 to that in 1994?
Provide a succinct answer. 0.88. What is the ratio of the % of GDP of Sweden in 1992 to that in 1994?
Ensure brevity in your answer.  1.13. What is the ratio of the % of GDP of Syrian Arab Republic in 1992 to that in 1994?
Make the answer very short. 0.77. What is the ratio of the % of GDP in Cameroon in 1992 to that in 1995?
Offer a terse response. 1.08. What is the ratio of the % of GDP in Kenya in 1992 to that in 1995?
Your response must be concise. 0.78. What is the ratio of the % of GDP of Sweden in 1992 to that in 1995?
Ensure brevity in your answer.  1.11. What is the ratio of the % of GDP of Syrian Arab Republic in 1992 to that in 1995?
Offer a terse response. 0.85. What is the ratio of the % of GDP of Cameroon in 1992 to that in 1996?
Your response must be concise. 1. What is the ratio of the % of GDP of Kenya in 1992 to that in 1996?
Your answer should be very brief. 1.13. What is the ratio of the % of GDP of Sweden in 1992 to that in 1996?
Ensure brevity in your answer.  1.12. What is the ratio of the % of GDP in Syrian Arab Republic in 1992 to that in 1996?
Provide a short and direct response. 0.97. What is the ratio of the % of GDP of Cameroon in 1993 to that in 1994?
Your answer should be compact. 1.09. What is the ratio of the % of GDP of Kenya in 1993 to that in 1994?
Make the answer very short. 0.91. What is the ratio of the % of GDP of Sweden in 1993 to that in 1994?
Give a very brief answer. 0.94. What is the ratio of the % of GDP in Syrian Arab Republic in 1993 to that in 1994?
Your answer should be compact. 0.87. What is the ratio of the % of GDP of Cameroon in 1993 to that in 1995?
Your response must be concise. 1.03. What is the ratio of the % of GDP of Kenya in 1993 to that in 1995?
Ensure brevity in your answer.  0.81. What is the ratio of the % of GDP in Sweden in 1993 to that in 1995?
Give a very brief answer. 0.92. What is the ratio of the % of GDP in Syrian Arab Republic in 1993 to that in 1995?
Your answer should be very brief. 0.95. What is the ratio of the % of GDP of Kenya in 1993 to that in 1996?
Ensure brevity in your answer.  1.17. What is the ratio of the % of GDP in Sweden in 1993 to that in 1996?
Provide a short and direct response. 0.93. What is the ratio of the % of GDP of Syrian Arab Republic in 1993 to that in 1996?
Provide a succinct answer. 1.09. What is the ratio of the % of GDP in Cameroon in 1994 to that in 1995?
Your answer should be compact. 0.95. What is the ratio of the % of GDP of Kenya in 1994 to that in 1995?
Make the answer very short. 0.88. What is the ratio of the % of GDP of Sweden in 1994 to that in 1995?
Keep it short and to the point. 0.98. What is the ratio of the % of GDP of Syrian Arab Republic in 1994 to that in 1995?
Provide a succinct answer. 1.1. What is the ratio of the % of GDP in Cameroon in 1994 to that in 1996?
Keep it short and to the point. 0.88. What is the ratio of the % of GDP of Kenya in 1994 to that in 1996?
Your answer should be compact. 1.29. What is the ratio of the % of GDP in Syrian Arab Republic in 1994 to that in 1996?
Your answer should be very brief. 1.25. What is the ratio of the % of GDP of Cameroon in 1995 to that in 1996?
Provide a short and direct response. 0.93. What is the ratio of the % of GDP in Kenya in 1995 to that in 1996?
Your response must be concise. 1.45. What is the ratio of the % of GDP in Sweden in 1995 to that in 1996?
Your answer should be compact. 1.01. What is the ratio of the % of GDP in Syrian Arab Republic in 1995 to that in 1996?
Your answer should be very brief. 1.14. What is the difference between the highest and the second highest % of GDP of Cameroon?
Make the answer very short. 0.72. What is the difference between the highest and the second highest % of GDP in Kenya?
Provide a short and direct response. 0.7. What is the difference between the highest and the second highest % of GDP in Sweden?
Your response must be concise. 0.58. What is the difference between the highest and the second highest % of GDP of Syrian Arab Republic?
Make the answer very short. 2.76. What is the difference between the highest and the lowest % of GDP in Cameroon?
Keep it short and to the point. 5.24. What is the difference between the highest and the lowest % of GDP in Kenya?
Provide a short and direct response. 9.86. What is the difference between the highest and the lowest % of GDP of Sweden?
Keep it short and to the point. 11.09. What is the difference between the highest and the lowest % of GDP in Syrian Arab Republic?
Offer a very short reply. 13.41. 